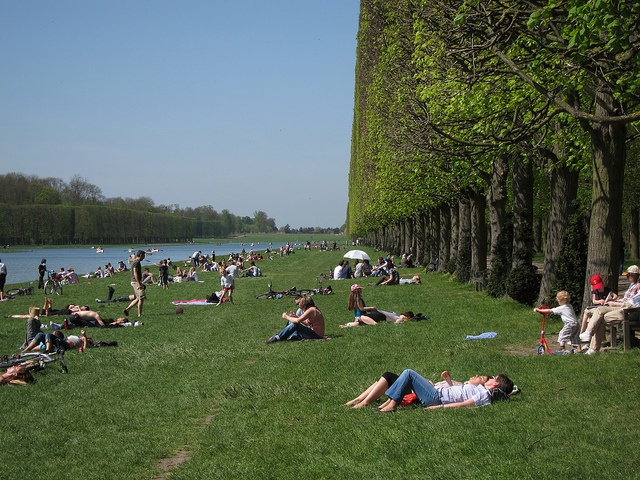Describe the objects in this image and their specific colors. I can see people in gray, darkgreen, and black tones, people in gray, black, and lavender tones, people in gray, lightgray, black, darkgray, and tan tones, people in gray, black, maroon, and darkgreen tones, and people in gray, lightgray, black, and darkgray tones in this image. 